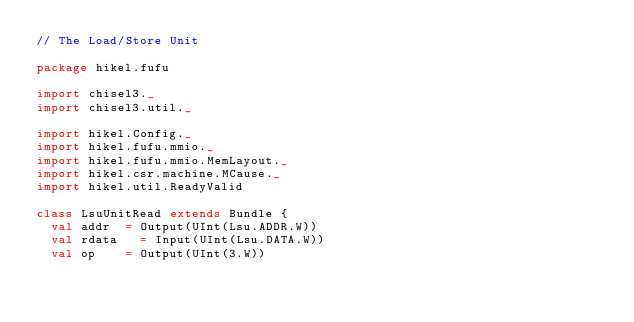Convert code to text. <code><loc_0><loc_0><loc_500><loc_500><_Scala_>// The Load/Store Unit

package hikel.fufu

import chisel3._
import chisel3.util._

import hikel.Config._
import hikel.fufu.mmio._
import hikel.fufu.mmio.MemLayout._
import hikel.csr.machine.MCause._
import hikel.util.ReadyValid

class LsuUnitRead extends Bundle {
	val addr 	= Output(UInt(Lsu.ADDR.W))
	val rdata 	= Input(UInt(Lsu.DATA.W))
	val op 		= Output(UInt(3.W))</code> 